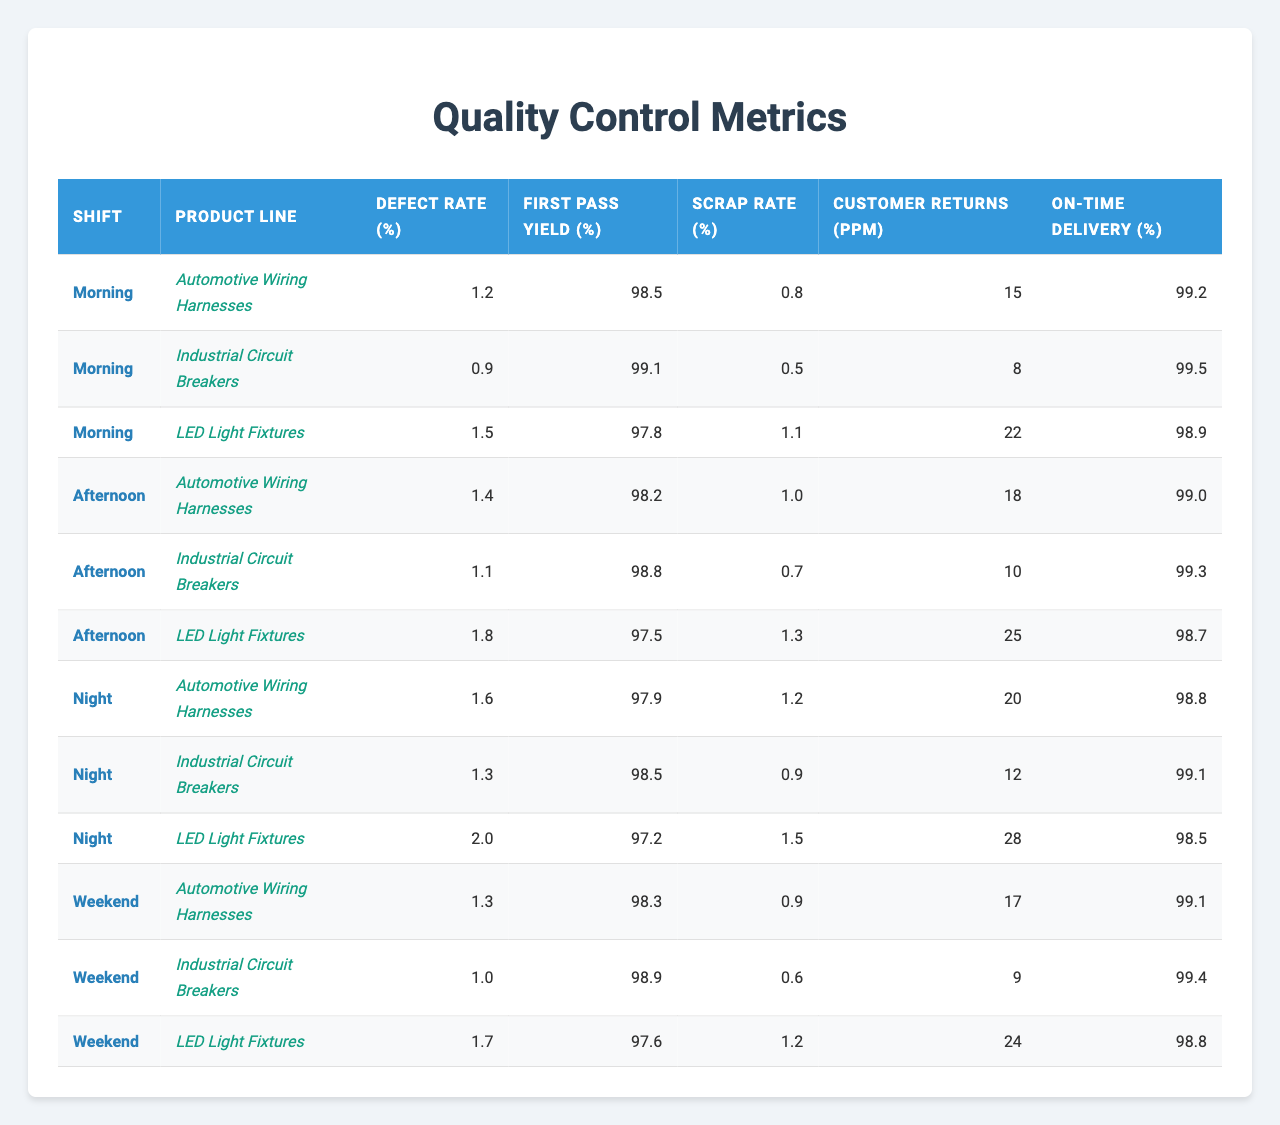What is the defect rate for Industrial Circuit Breakers on the Afternoon shift? Looking at the table under the Afternoon shift and the Industrial Circuit Breakers row, the defect rate is listed as 1.1%.
Answer: 1.1% What is the First Pass Yield percentage for LED Light Fixtures during the Night shift? The Night shift for LED Light Fixtures shows a First Pass Yield of 97.2%.
Answer: 97.2% Which product line has the highest scrap rate in the Morning shift? In the Morning shift, the LED Light Fixtures have a scrap rate of 1.1%, which is the highest compared to other product lines.
Answer: LED Light Fixtures What shift has the lowest defect rate for Automotive Wiring Harnesses? The Morning shift has a defect rate of 1.2%, while the Afternoon and Night shifts have rates of 1.4% and 1.6%, respectively. Thus, the Morning shift has the lowest defect rate.
Answer: Morning What is the average On-Time Delivery percentage for all product lines on the Weekend? The On-Time Delivery percentages for the Weekend are 99.1%, 99.4%, and 98.8%. The total is 99.1 + 99.4 + 98.8 = 297.3, which when divided by 3 gives an average of 99.1%.
Answer: 99.1% How does the defect rate for LED Light Fixtures compare between the Morning and Night shifts? The defect rate for the Morning shift is 1.5%, while for the Night shift it is 2.0%. Since 2.0% is higher than 1.5%, the Night shift has a higher defect rate.
Answer: Night shift has a higher defect rate Is the Customer Returns rate for Industrial Circuit Breakers higher during the Afternoon shift compared to the Morning shift? The Customer Returns (ppm) for the Afternoon shift is 10 ppm, and for the Morning shift it is 8 ppm. Since 10 is greater than 8, the Afternoon shift has a higher returns rate.
Answer: Yes Which product line has the best First Pass Yield in the Night shift? In the Night shift, Automotive Wiring Harnesses have the highest First Pass Yield at 97.9%, compared to Industrial Circuit Breakers at 98.5% and LED Light Fixtures at 97.2%.
Answer: Industrial Circuit Breakers What is the difference in scrap rate between the Morning and Afternoon shifts for Automotive Wiring Harnesses? The scrap rate in the Morning shift for Automotive Wiring Harnesses is 0.8%, and in the Afternoon shift, it is 1.0%. The difference is 1.0% - 0.8% = 0.2%.
Answer: 0.2% Which shift and product line combination has the highest Customer Returns? Looking at the table, the LED Light Fixtures in the Night shift have the highest Customer Returns at 28 ppm.
Answer: Night shift, LED Light Fixtures Is the On-Time Delivery percentage lower for Automotive Wiring Harnesses on the Night shift compared to the Morning shift? The On-Time Delivery for Automotive Wiring Harnesses is 98.8% on the Night shift and 99.2% on the Morning shift. So, yes, it is lower on the Night shift.
Answer: Yes 